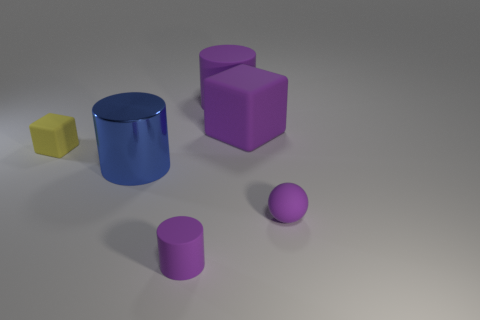Subtract all large blue shiny cylinders. How many cylinders are left? 2 Add 1 rubber spheres. How many objects exist? 7 Subtract all blue cylinders. How many cylinders are left? 2 Subtract all red cubes. How many purple cylinders are left? 2 Subtract all cubes. How many objects are left? 4 Subtract 1 cylinders. How many cylinders are left? 2 Subtract all gray spheres. Subtract all yellow blocks. How many spheres are left? 1 Subtract all big purple rubber things. Subtract all large red things. How many objects are left? 4 Add 6 tiny rubber cylinders. How many tiny rubber cylinders are left? 7 Add 2 tiny brown rubber blocks. How many tiny brown rubber blocks exist? 2 